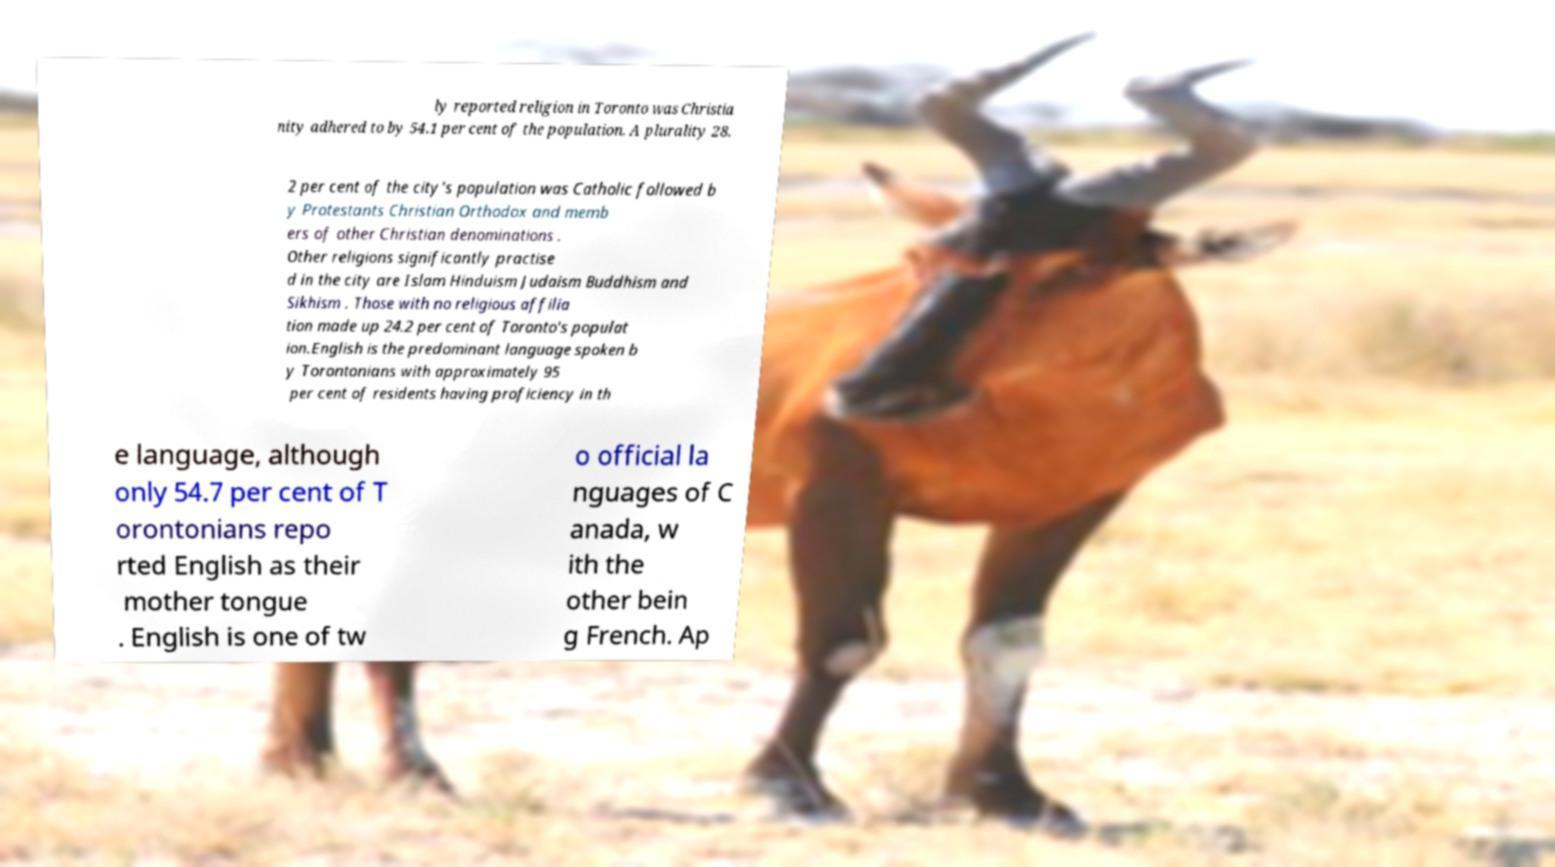For documentation purposes, I need the text within this image transcribed. Could you provide that? ly reported religion in Toronto was Christia nity adhered to by 54.1 per cent of the population. A plurality 28. 2 per cent of the city's population was Catholic followed b y Protestants Christian Orthodox and memb ers of other Christian denominations . Other religions significantly practise d in the city are Islam Hinduism Judaism Buddhism and Sikhism . Those with no religious affilia tion made up 24.2 per cent of Toronto's populat ion.English is the predominant language spoken b y Torontonians with approximately 95 per cent of residents having proficiency in th e language, although only 54.7 per cent of T orontonians repo rted English as their mother tongue . English is one of tw o official la nguages of C anada, w ith the other bein g French. Ap 